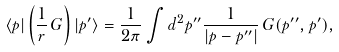<formula> <loc_0><loc_0><loc_500><loc_500>\langle p | \left ( \frac { 1 } { r } \, G \right ) | p ^ { \prime } \rangle = \frac { 1 } { 2 \pi } \int d ^ { 2 } p ^ { \prime \prime } \frac { 1 } { | p - p ^ { \prime \prime } | } \, G ( p ^ { \prime \prime } , p ^ { \prime } ) ,</formula> 